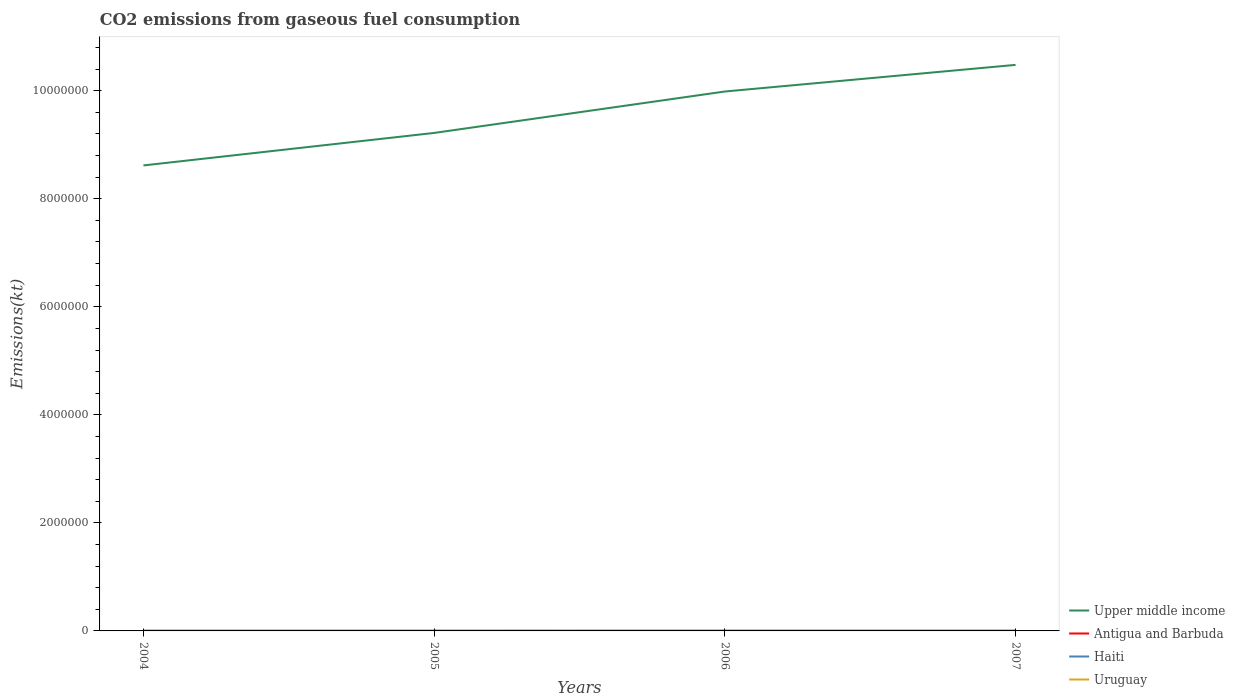Across all years, what is the maximum amount of CO2 emitted in Haiti?
Your response must be concise. 1987.51. What is the total amount of CO2 emitted in Antigua and Barbuda in the graph?
Keep it short and to the point. -18.34. What is the difference between the highest and the second highest amount of CO2 emitted in Uruguay?
Provide a succinct answer. 1037.76. What is the difference between two consecutive major ticks on the Y-axis?
Keep it short and to the point. 2.00e+06. Does the graph contain any zero values?
Offer a terse response. No. Does the graph contain grids?
Keep it short and to the point. No. Where does the legend appear in the graph?
Your response must be concise. Bottom right. How many legend labels are there?
Provide a short and direct response. 4. How are the legend labels stacked?
Offer a terse response. Vertical. What is the title of the graph?
Your answer should be compact. CO2 emissions from gaseous fuel consumption. Does "Liberia" appear as one of the legend labels in the graph?
Ensure brevity in your answer.  No. What is the label or title of the X-axis?
Your response must be concise. Years. What is the label or title of the Y-axis?
Your response must be concise. Emissions(kt). What is the Emissions(kt) of Upper middle income in 2004?
Your answer should be compact. 8.62e+06. What is the Emissions(kt) of Antigua and Barbuda in 2004?
Provide a short and direct response. 407.04. What is the Emissions(kt) of Haiti in 2004?
Offer a terse response. 1987.51. What is the Emissions(kt) in Uruguay in 2004?
Provide a succinct answer. 5610.51. What is the Emissions(kt) of Upper middle income in 2005?
Make the answer very short. 9.22e+06. What is the Emissions(kt) in Antigua and Barbuda in 2005?
Your answer should be very brief. 410.7. What is the Emissions(kt) in Haiti in 2005?
Your answer should be compact. 2075.52. What is the Emissions(kt) of Uruguay in 2005?
Provide a short and direct response. 5775.52. What is the Emissions(kt) of Upper middle income in 2006?
Offer a terse response. 9.99e+06. What is the Emissions(kt) in Antigua and Barbuda in 2006?
Ensure brevity in your answer.  425.37. What is the Emissions(kt) of Haiti in 2006?
Make the answer very short. 2112.19. What is the Emissions(kt) of Uruguay in 2006?
Keep it short and to the point. 6648.27. What is the Emissions(kt) in Upper middle income in 2007?
Provide a short and direct response. 1.05e+07. What is the Emissions(kt) in Antigua and Barbuda in 2007?
Offer a very short reply. 469.38. What is the Emissions(kt) of Haiti in 2007?
Keep it short and to the point. 2390.88. What is the Emissions(kt) of Uruguay in 2007?
Your answer should be compact. 5999.21. Across all years, what is the maximum Emissions(kt) of Upper middle income?
Ensure brevity in your answer.  1.05e+07. Across all years, what is the maximum Emissions(kt) in Antigua and Barbuda?
Make the answer very short. 469.38. Across all years, what is the maximum Emissions(kt) of Haiti?
Make the answer very short. 2390.88. Across all years, what is the maximum Emissions(kt) of Uruguay?
Ensure brevity in your answer.  6648.27. Across all years, what is the minimum Emissions(kt) in Upper middle income?
Your answer should be compact. 8.62e+06. Across all years, what is the minimum Emissions(kt) in Antigua and Barbuda?
Your response must be concise. 407.04. Across all years, what is the minimum Emissions(kt) in Haiti?
Your answer should be compact. 1987.51. Across all years, what is the minimum Emissions(kt) of Uruguay?
Your answer should be compact. 5610.51. What is the total Emissions(kt) of Upper middle income in the graph?
Keep it short and to the point. 3.83e+07. What is the total Emissions(kt) of Antigua and Barbuda in the graph?
Provide a short and direct response. 1712.49. What is the total Emissions(kt) of Haiti in the graph?
Offer a terse response. 8566.11. What is the total Emissions(kt) in Uruguay in the graph?
Your answer should be very brief. 2.40e+04. What is the difference between the Emissions(kt) of Upper middle income in 2004 and that in 2005?
Ensure brevity in your answer.  -6.02e+05. What is the difference between the Emissions(kt) of Antigua and Barbuda in 2004 and that in 2005?
Offer a very short reply. -3.67. What is the difference between the Emissions(kt) in Haiti in 2004 and that in 2005?
Your answer should be very brief. -88.01. What is the difference between the Emissions(kt) in Uruguay in 2004 and that in 2005?
Offer a terse response. -165.01. What is the difference between the Emissions(kt) of Upper middle income in 2004 and that in 2006?
Keep it short and to the point. -1.37e+06. What is the difference between the Emissions(kt) of Antigua and Barbuda in 2004 and that in 2006?
Your answer should be very brief. -18.34. What is the difference between the Emissions(kt) of Haiti in 2004 and that in 2006?
Ensure brevity in your answer.  -124.68. What is the difference between the Emissions(kt) in Uruguay in 2004 and that in 2006?
Offer a very short reply. -1037.76. What is the difference between the Emissions(kt) of Upper middle income in 2004 and that in 2007?
Provide a succinct answer. -1.86e+06. What is the difference between the Emissions(kt) in Antigua and Barbuda in 2004 and that in 2007?
Your answer should be very brief. -62.34. What is the difference between the Emissions(kt) of Haiti in 2004 and that in 2007?
Offer a terse response. -403.37. What is the difference between the Emissions(kt) in Uruguay in 2004 and that in 2007?
Make the answer very short. -388.7. What is the difference between the Emissions(kt) in Upper middle income in 2005 and that in 2006?
Give a very brief answer. -7.67e+05. What is the difference between the Emissions(kt) in Antigua and Barbuda in 2005 and that in 2006?
Provide a succinct answer. -14.67. What is the difference between the Emissions(kt) of Haiti in 2005 and that in 2006?
Your response must be concise. -36.67. What is the difference between the Emissions(kt) of Uruguay in 2005 and that in 2006?
Give a very brief answer. -872.75. What is the difference between the Emissions(kt) in Upper middle income in 2005 and that in 2007?
Your response must be concise. -1.26e+06. What is the difference between the Emissions(kt) in Antigua and Barbuda in 2005 and that in 2007?
Provide a succinct answer. -58.67. What is the difference between the Emissions(kt) in Haiti in 2005 and that in 2007?
Give a very brief answer. -315.36. What is the difference between the Emissions(kt) in Uruguay in 2005 and that in 2007?
Provide a succinct answer. -223.69. What is the difference between the Emissions(kt) in Upper middle income in 2006 and that in 2007?
Offer a very short reply. -4.93e+05. What is the difference between the Emissions(kt) of Antigua and Barbuda in 2006 and that in 2007?
Provide a succinct answer. -44. What is the difference between the Emissions(kt) of Haiti in 2006 and that in 2007?
Provide a succinct answer. -278.69. What is the difference between the Emissions(kt) in Uruguay in 2006 and that in 2007?
Offer a terse response. 649.06. What is the difference between the Emissions(kt) in Upper middle income in 2004 and the Emissions(kt) in Antigua and Barbuda in 2005?
Ensure brevity in your answer.  8.62e+06. What is the difference between the Emissions(kt) in Upper middle income in 2004 and the Emissions(kt) in Haiti in 2005?
Your answer should be very brief. 8.62e+06. What is the difference between the Emissions(kt) of Upper middle income in 2004 and the Emissions(kt) of Uruguay in 2005?
Offer a terse response. 8.61e+06. What is the difference between the Emissions(kt) in Antigua and Barbuda in 2004 and the Emissions(kt) in Haiti in 2005?
Provide a succinct answer. -1668.48. What is the difference between the Emissions(kt) in Antigua and Barbuda in 2004 and the Emissions(kt) in Uruguay in 2005?
Make the answer very short. -5368.49. What is the difference between the Emissions(kt) in Haiti in 2004 and the Emissions(kt) in Uruguay in 2005?
Offer a very short reply. -3788.01. What is the difference between the Emissions(kt) in Upper middle income in 2004 and the Emissions(kt) in Antigua and Barbuda in 2006?
Make the answer very short. 8.62e+06. What is the difference between the Emissions(kt) of Upper middle income in 2004 and the Emissions(kt) of Haiti in 2006?
Offer a terse response. 8.62e+06. What is the difference between the Emissions(kt) of Upper middle income in 2004 and the Emissions(kt) of Uruguay in 2006?
Give a very brief answer. 8.61e+06. What is the difference between the Emissions(kt) of Antigua and Barbuda in 2004 and the Emissions(kt) of Haiti in 2006?
Make the answer very short. -1705.15. What is the difference between the Emissions(kt) of Antigua and Barbuda in 2004 and the Emissions(kt) of Uruguay in 2006?
Provide a short and direct response. -6241.23. What is the difference between the Emissions(kt) in Haiti in 2004 and the Emissions(kt) in Uruguay in 2006?
Give a very brief answer. -4660.76. What is the difference between the Emissions(kt) in Upper middle income in 2004 and the Emissions(kt) in Antigua and Barbuda in 2007?
Offer a very short reply. 8.62e+06. What is the difference between the Emissions(kt) in Upper middle income in 2004 and the Emissions(kt) in Haiti in 2007?
Ensure brevity in your answer.  8.61e+06. What is the difference between the Emissions(kt) of Upper middle income in 2004 and the Emissions(kt) of Uruguay in 2007?
Offer a very short reply. 8.61e+06. What is the difference between the Emissions(kt) of Antigua and Barbuda in 2004 and the Emissions(kt) of Haiti in 2007?
Give a very brief answer. -1983.85. What is the difference between the Emissions(kt) of Antigua and Barbuda in 2004 and the Emissions(kt) of Uruguay in 2007?
Make the answer very short. -5592.18. What is the difference between the Emissions(kt) of Haiti in 2004 and the Emissions(kt) of Uruguay in 2007?
Keep it short and to the point. -4011.7. What is the difference between the Emissions(kt) of Upper middle income in 2005 and the Emissions(kt) of Antigua and Barbuda in 2006?
Your answer should be compact. 9.22e+06. What is the difference between the Emissions(kt) in Upper middle income in 2005 and the Emissions(kt) in Haiti in 2006?
Your answer should be compact. 9.22e+06. What is the difference between the Emissions(kt) of Upper middle income in 2005 and the Emissions(kt) of Uruguay in 2006?
Your answer should be very brief. 9.21e+06. What is the difference between the Emissions(kt) in Antigua and Barbuda in 2005 and the Emissions(kt) in Haiti in 2006?
Give a very brief answer. -1701.49. What is the difference between the Emissions(kt) of Antigua and Barbuda in 2005 and the Emissions(kt) of Uruguay in 2006?
Offer a terse response. -6237.57. What is the difference between the Emissions(kt) of Haiti in 2005 and the Emissions(kt) of Uruguay in 2006?
Provide a short and direct response. -4572.75. What is the difference between the Emissions(kt) in Upper middle income in 2005 and the Emissions(kt) in Antigua and Barbuda in 2007?
Your answer should be very brief. 9.22e+06. What is the difference between the Emissions(kt) of Upper middle income in 2005 and the Emissions(kt) of Haiti in 2007?
Your answer should be compact. 9.22e+06. What is the difference between the Emissions(kt) in Upper middle income in 2005 and the Emissions(kt) in Uruguay in 2007?
Provide a short and direct response. 9.21e+06. What is the difference between the Emissions(kt) in Antigua and Barbuda in 2005 and the Emissions(kt) in Haiti in 2007?
Your response must be concise. -1980.18. What is the difference between the Emissions(kt) of Antigua and Barbuda in 2005 and the Emissions(kt) of Uruguay in 2007?
Provide a short and direct response. -5588.51. What is the difference between the Emissions(kt) in Haiti in 2005 and the Emissions(kt) in Uruguay in 2007?
Your answer should be compact. -3923.69. What is the difference between the Emissions(kt) of Upper middle income in 2006 and the Emissions(kt) of Antigua and Barbuda in 2007?
Provide a succinct answer. 9.99e+06. What is the difference between the Emissions(kt) of Upper middle income in 2006 and the Emissions(kt) of Haiti in 2007?
Make the answer very short. 9.98e+06. What is the difference between the Emissions(kt) in Upper middle income in 2006 and the Emissions(kt) in Uruguay in 2007?
Give a very brief answer. 9.98e+06. What is the difference between the Emissions(kt) of Antigua and Barbuda in 2006 and the Emissions(kt) of Haiti in 2007?
Make the answer very short. -1965.51. What is the difference between the Emissions(kt) of Antigua and Barbuda in 2006 and the Emissions(kt) of Uruguay in 2007?
Provide a succinct answer. -5573.84. What is the difference between the Emissions(kt) of Haiti in 2006 and the Emissions(kt) of Uruguay in 2007?
Provide a succinct answer. -3887.02. What is the average Emissions(kt) of Upper middle income per year?
Offer a very short reply. 9.58e+06. What is the average Emissions(kt) in Antigua and Barbuda per year?
Provide a succinct answer. 428.12. What is the average Emissions(kt) of Haiti per year?
Your answer should be very brief. 2141.53. What is the average Emissions(kt) in Uruguay per year?
Your response must be concise. 6008.38. In the year 2004, what is the difference between the Emissions(kt) in Upper middle income and Emissions(kt) in Antigua and Barbuda?
Offer a terse response. 8.62e+06. In the year 2004, what is the difference between the Emissions(kt) in Upper middle income and Emissions(kt) in Haiti?
Ensure brevity in your answer.  8.62e+06. In the year 2004, what is the difference between the Emissions(kt) in Upper middle income and Emissions(kt) in Uruguay?
Your answer should be compact. 8.61e+06. In the year 2004, what is the difference between the Emissions(kt) in Antigua and Barbuda and Emissions(kt) in Haiti?
Offer a terse response. -1580.48. In the year 2004, what is the difference between the Emissions(kt) of Antigua and Barbuda and Emissions(kt) of Uruguay?
Your response must be concise. -5203.47. In the year 2004, what is the difference between the Emissions(kt) in Haiti and Emissions(kt) in Uruguay?
Offer a terse response. -3623. In the year 2005, what is the difference between the Emissions(kt) of Upper middle income and Emissions(kt) of Antigua and Barbuda?
Make the answer very short. 9.22e+06. In the year 2005, what is the difference between the Emissions(kt) of Upper middle income and Emissions(kt) of Haiti?
Provide a short and direct response. 9.22e+06. In the year 2005, what is the difference between the Emissions(kt) in Upper middle income and Emissions(kt) in Uruguay?
Give a very brief answer. 9.21e+06. In the year 2005, what is the difference between the Emissions(kt) of Antigua and Barbuda and Emissions(kt) of Haiti?
Offer a terse response. -1664.82. In the year 2005, what is the difference between the Emissions(kt) in Antigua and Barbuda and Emissions(kt) in Uruguay?
Your answer should be very brief. -5364.82. In the year 2005, what is the difference between the Emissions(kt) in Haiti and Emissions(kt) in Uruguay?
Make the answer very short. -3700. In the year 2006, what is the difference between the Emissions(kt) of Upper middle income and Emissions(kt) of Antigua and Barbuda?
Make the answer very short. 9.99e+06. In the year 2006, what is the difference between the Emissions(kt) in Upper middle income and Emissions(kt) in Haiti?
Provide a short and direct response. 9.98e+06. In the year 2006, what is the difference between the Emissions(kt) in Upper middle income and Emissions(kt) in Uruguay?
Keep it short and to the point. 9.98e+06. In the year 2006, what is the difference between the Emissions(kt) in Antigua and Barbuda and Emissions(kt) in Haiti?
Your answer should be very brief. -1686.82. In the year 2006, what is the difference between the Emissions(kt) of Antigua and Barbuda and Emissions(kt) of Uruguay?
Offer a terse response. -6222.9. In the year 2006, what is the difference between the Emissions(kt) of Haiti and Emissions(kt) of Uruguay?
Make the answer very short. -4536.08. In the year 2007, what is the difference between the Emissions(kt) in Upper middle income and Emissions(kt) in Antigua and Barbuda?
Offer a very short reply. 1.05e+07. In the year 2007, what is the difference between the Emissions(kt) of Upper middle income and Emissions(kt) of Haiti?
Your response must be concise. 1.05e+07. In the year 2007, what is the difference between the Emissions(kt) of Upper middle income and Emissions(kt) of Uruguay?
Make the answer very short. 1.05e+07. In the year 2007, what is the difference between the Emissions(kt) in Antigua and Barbuda and Emissions(kt) in Haiti?
Offer a very short reply. -1921.51. In the year 2007, what is the difference between the Emissions(kt) of Antigua and Barbuda and Emissions(kt) of Uruguay?
Give a very brief answer. -5529.84. In the year 2007, what is the difference between the Emissions(kt) of Haiti and Emissions(kt) of Uruguay?
Ensure brevity in your answer.  -3608.33. What is the ratio of the Emissions(kt) in Upper middle income in 2004 to that in 2005?
Make the answer very short. 0.93. What is the ratio of the Emissions(kt) in Haiti in 2004 to that in 2005?
Ensure brevity in your answer.  0.96. What is the ratio of the Emissions(kt) of Uruguay in 2004 to that in 2005?
Your answer should be very brief. 0.97. What is the ratio of the Emissions(kt) in Upper middle income in 2004 to that in 2006?
Provide a succinct answer. 0.86. What is the ratio of the Emissions(kt) of Antigua and Barbuda in 2004 to that in 2006?
Make the answer very short. 0.96. What is the ratio of the Emissions(kt) in Haiti in 2004 to that in 2006?
Give a very brief answer. 0.94. What is the ratio of the Emissions(kt) in Uruguay in 2004 to that in 2006?
Your answer should be compact. 0.84. What is the ratio of the Emissions(kt) of Upper middle income in 2004 to that in 2007?
Give a very brief answer. 0.82. What is the ratio of the Emissions(kt) in Antigua and Barbuda in 2004 to that in 2007?
Offer a very short reply. 0.87. What is the ratio of the Emissions(kt) in Haiti in 2004 to that in 2007?
Offer a terse response. 0.83. What is the ratio of the Emissions(kt) in Uruguay in 2004 to that in 2007?
Offer a very short reply. 0.94. What is the ratio of the Emissions(kt) in Upper middle income in 2005 to that in 2006?
Your answer should be very brief. 0.92. What is the ratio of the Emissions(kt) in Antigua and Barbuda in 2005 to that in 2006?
Ensure brevity in your answer.  0.97. What is the ratio of the Emissions(kt) of Haiti in 2005 to that in 2006?
Offer a terse response. 0.98. What is the ratio of the Emissions(kt) of Uruguay in 2005 to that in 2006?
Your response must be concise. 0.87. What is the ratio of the Emissions(kt) of Upper middle income in 2005 to that in 2007?
Keep it short and to the point. 0.88. What is the ratio of the Emissions(kt) of Haiti in 2005 to that in 2007?
Your answer should be very brief. 0.87. What is the ratio of the Emissions(kt) in Uruguay in 2005 to that in 2007?
Keep it short and to the point. 0.96. What is the ratio of the Emissions(kt) of Upper middle income in 2006 to that in 2007?
Make the answer very short. 0.95. What is the ratio of the Emissions(kt) in Antigua and Barbuda in 2006 to that in 2007?
Make the answer very short. 0.91. What is the ratio of the Emissions(kt) of Haiti in 2006 to that in 2007?
Ensure brevity in your answer.  0.88. What is the ratio of the Emissions(kt) of Uruguay in 2006 to that in 2007?
Give a very brief answer. 1.11. What is the difference between the highest and the second highest Emissions(kt) in Upper middle income?
Give a very brief answer. 4.93e+05. What is the difference between the highest and the second highest Emissions(kt) of Antigua and Barbuda?
Your response must be concise. 44. What is the difference between the highest and the second highest Emissions(kt) in Haiti?
Your answer should be very brief. 278.69. What is the difference between the highest and the second highest Emissions(kt) in Uruguay?
Keep it short and to the point. 649.06. What is the difference between the highest and the lowest Emissions(kt) in Upper middle income?
Your response must be concise. 1.86e+06. What is the difference between the highest and the lowest Emissions(kt) in Antigua and Barbuda?
Offer a very short reply. 62.34. What is the difference between the highest and the lowest Emissions(kt) of Haiti?
Provide a short and direct response. 403.37. What is the difference between the highest and the lowest Emissions(kt) of Uruguay?
Ensure brevity in your answer.  1037.76. 